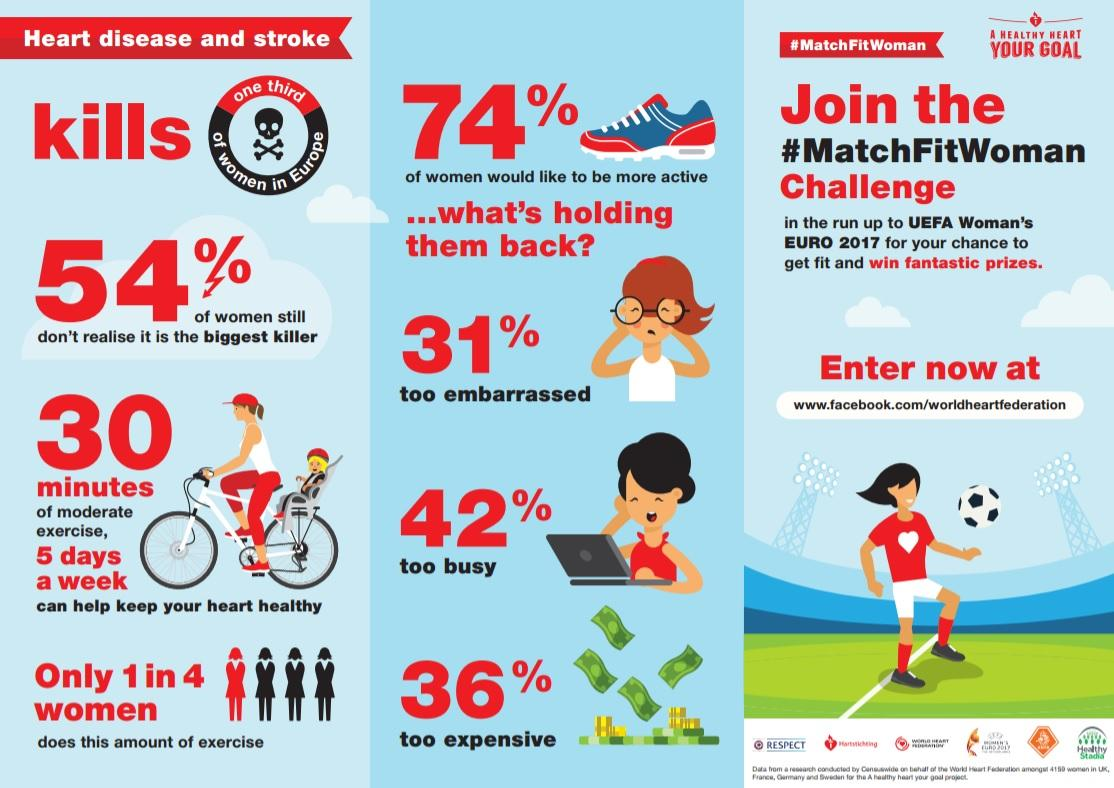Outline some significant characteristics in this image. The primary reason that hinders women from being more active is due to being too busy. The hashtag mentioned is #MatchFitWoman. A proportion of women do not do 30 minutes of moderate exercise 5 days a week, which is equivalent to three out of four. 